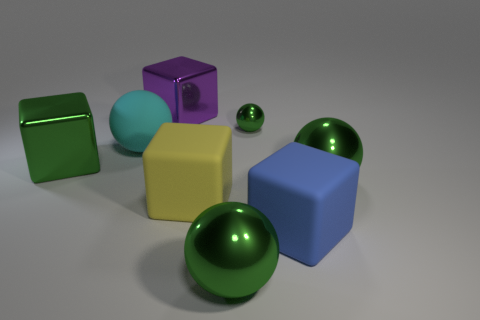Do the big purple block that is on the left side of the big yellow matte block and the blue block have the same material?
Offer a terse response. No. What size is the metallic ball behind the green shiny object on the left side of the large cyan rubber sphere?
Ensure brevity in your answer.  Small. What is the size of the rubber object on the right side of the big green metal sphere in front of the big green shiny sphere that is behind the big blue rubber block?
Keep it short and to the point. Large. Does the big thing that is behind the large cyan rubber sphere have the same shape as the big metal thing that is to the right of the small metal ball?
Your response must be concise. No. How many other things are the same color as the tiny thing?
Make the answer very short. 3. There is a ball to the left of the purple shiny cube; does it have the same size as the large green block?
Keep it short and to the point. Yes. Is the green sphere in front of the yellow thing made of the same material as the object that is behind the tiny sphere?
Make the answer very short. Yes. Is there a green sphere of the same size as the cyan rubber sphere?
Your answer should be compact. Yes. The large thing left of the large sphere left of the big green sphere in front of the blue object is what shape?
Offer a terse response. Cube. Are there more cubes that are on the right side of the big yellow object than red metal things?
Provide a short and direct response. Yes. 